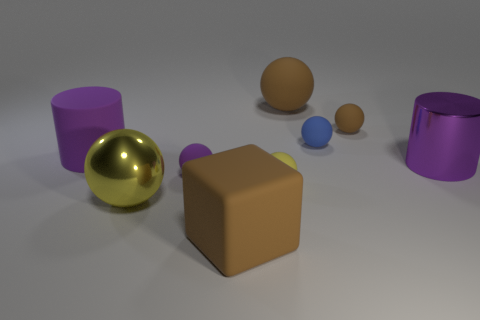Subtract all purple spheres. How many spheres are left? 5 Subtract all tiny brown rubber spheres. How many spheres are left? 5 Subtract all cyan balls. Subtract all purple blocks. How many balls are left? 6 Add 1 yellow spheres. How many objects exist? 10 Subtract all cylinders. How many objects are left? 7 Subtract 1 purple cylinders. How many objects are left? 8 Subtract all large purple matte cylinders. Subtract all large brown things. How many objects are left? 6 Add 3 big brown blocks. How many big brown blocks are left? 4 Add 3 yellow rubber balls. How many yellow rubber balls exist? 4 